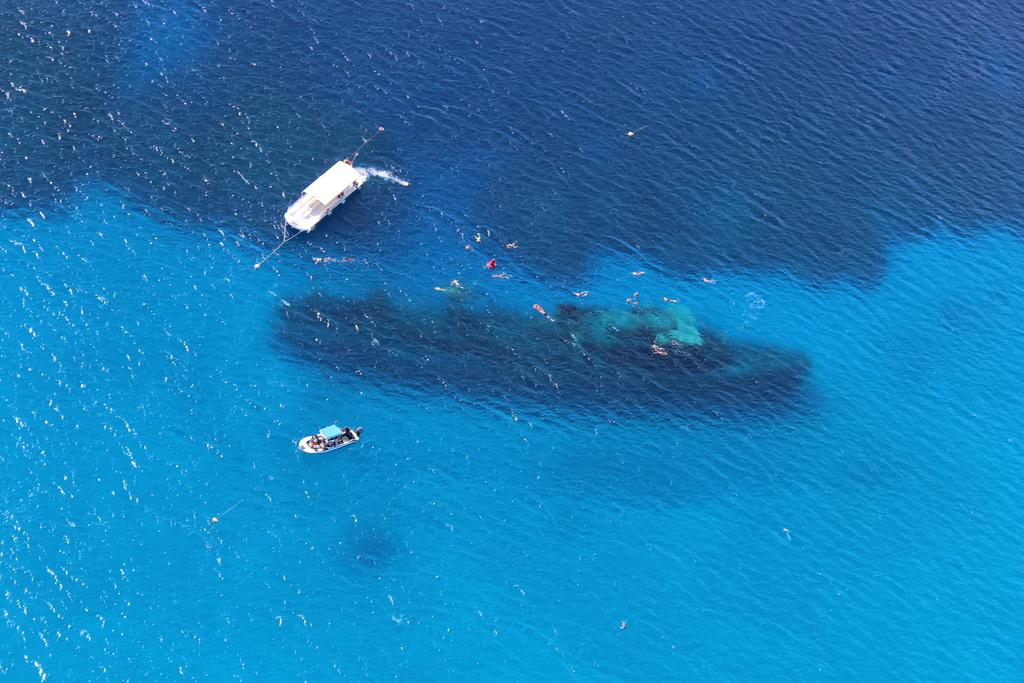What is the main setting of the image? The image consists of an ocean. Are there any objects present in the ocean? Yes, there are two boats in the ocean. Is there anything else underwater in the image? Yes, there is a submarine under the water in the image. What type of string can be seen connecting the two boats in the image? There is no string connecting the two boats in the image; they are separate entities in the ocean. 